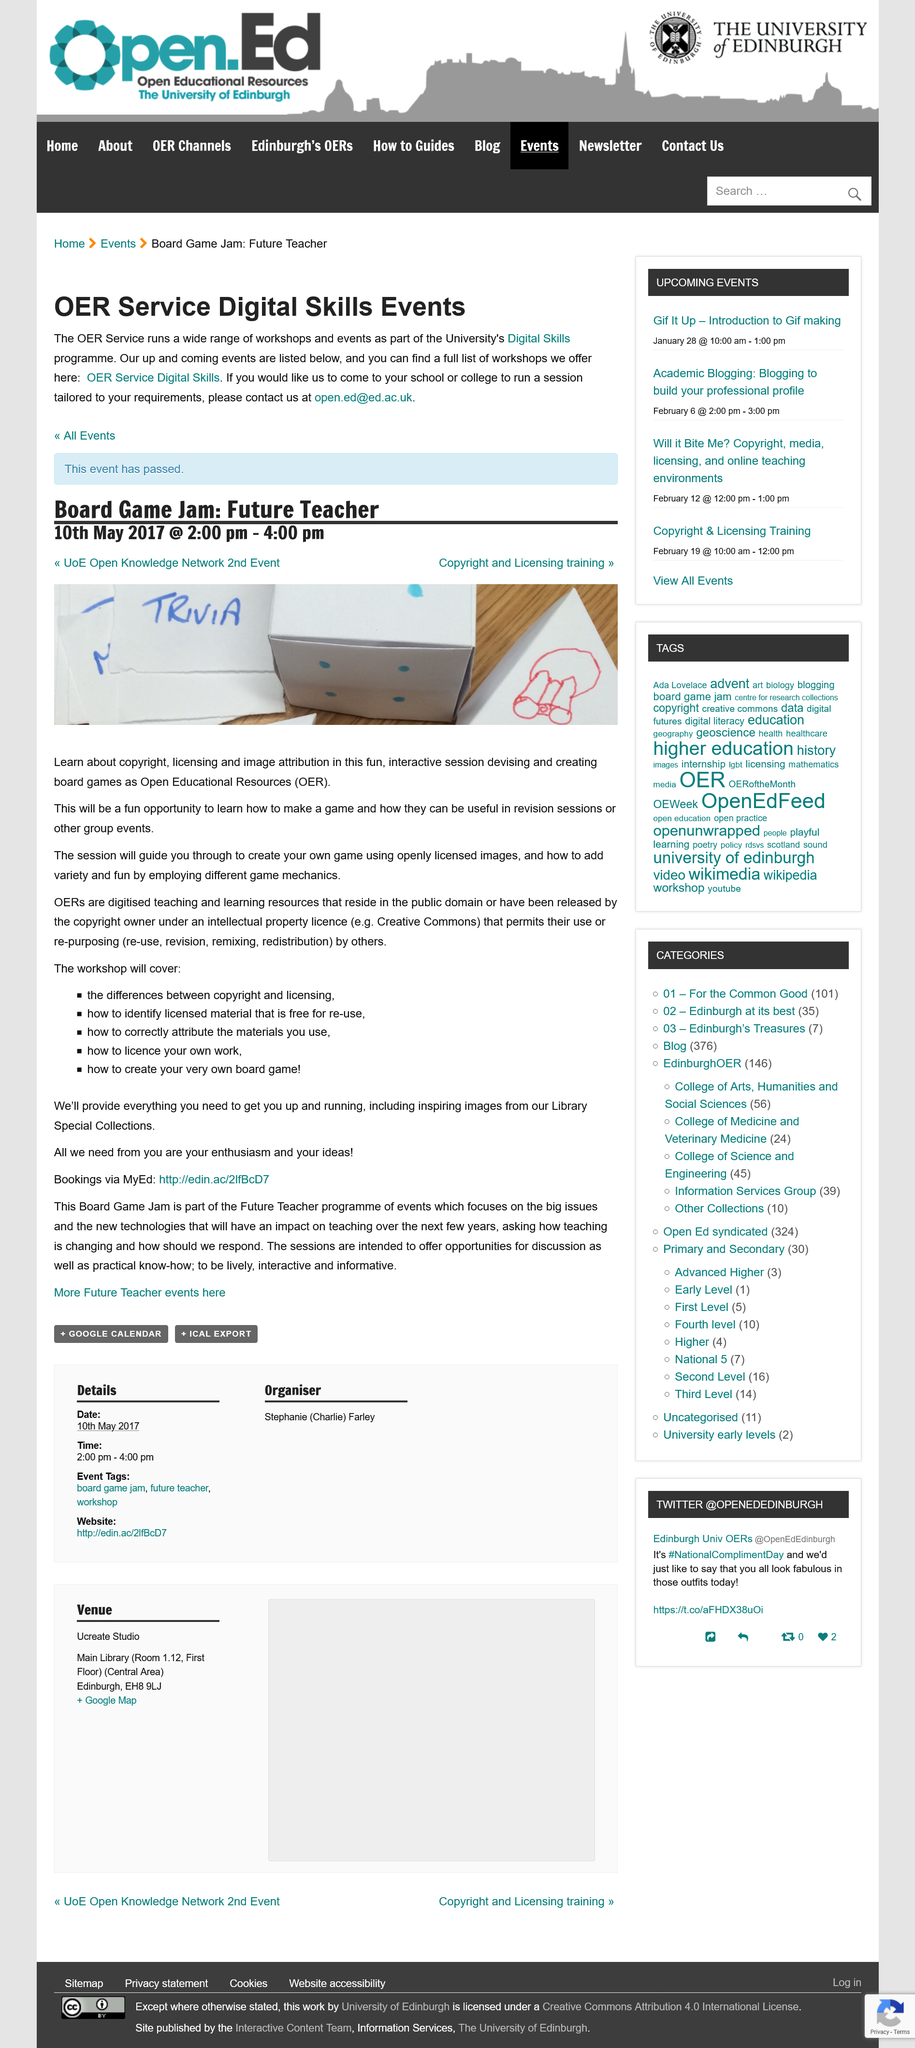Specify some key components in this picture. The workshop will cover five areas in total. The event is expected to last for two hours, between 2:00 PM and 4:00 PM. Open Educational Resources is defined as OER. 